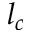<formula> <loc_0><loc_0><loc_500><loc_500>l _ { c }</formula> 